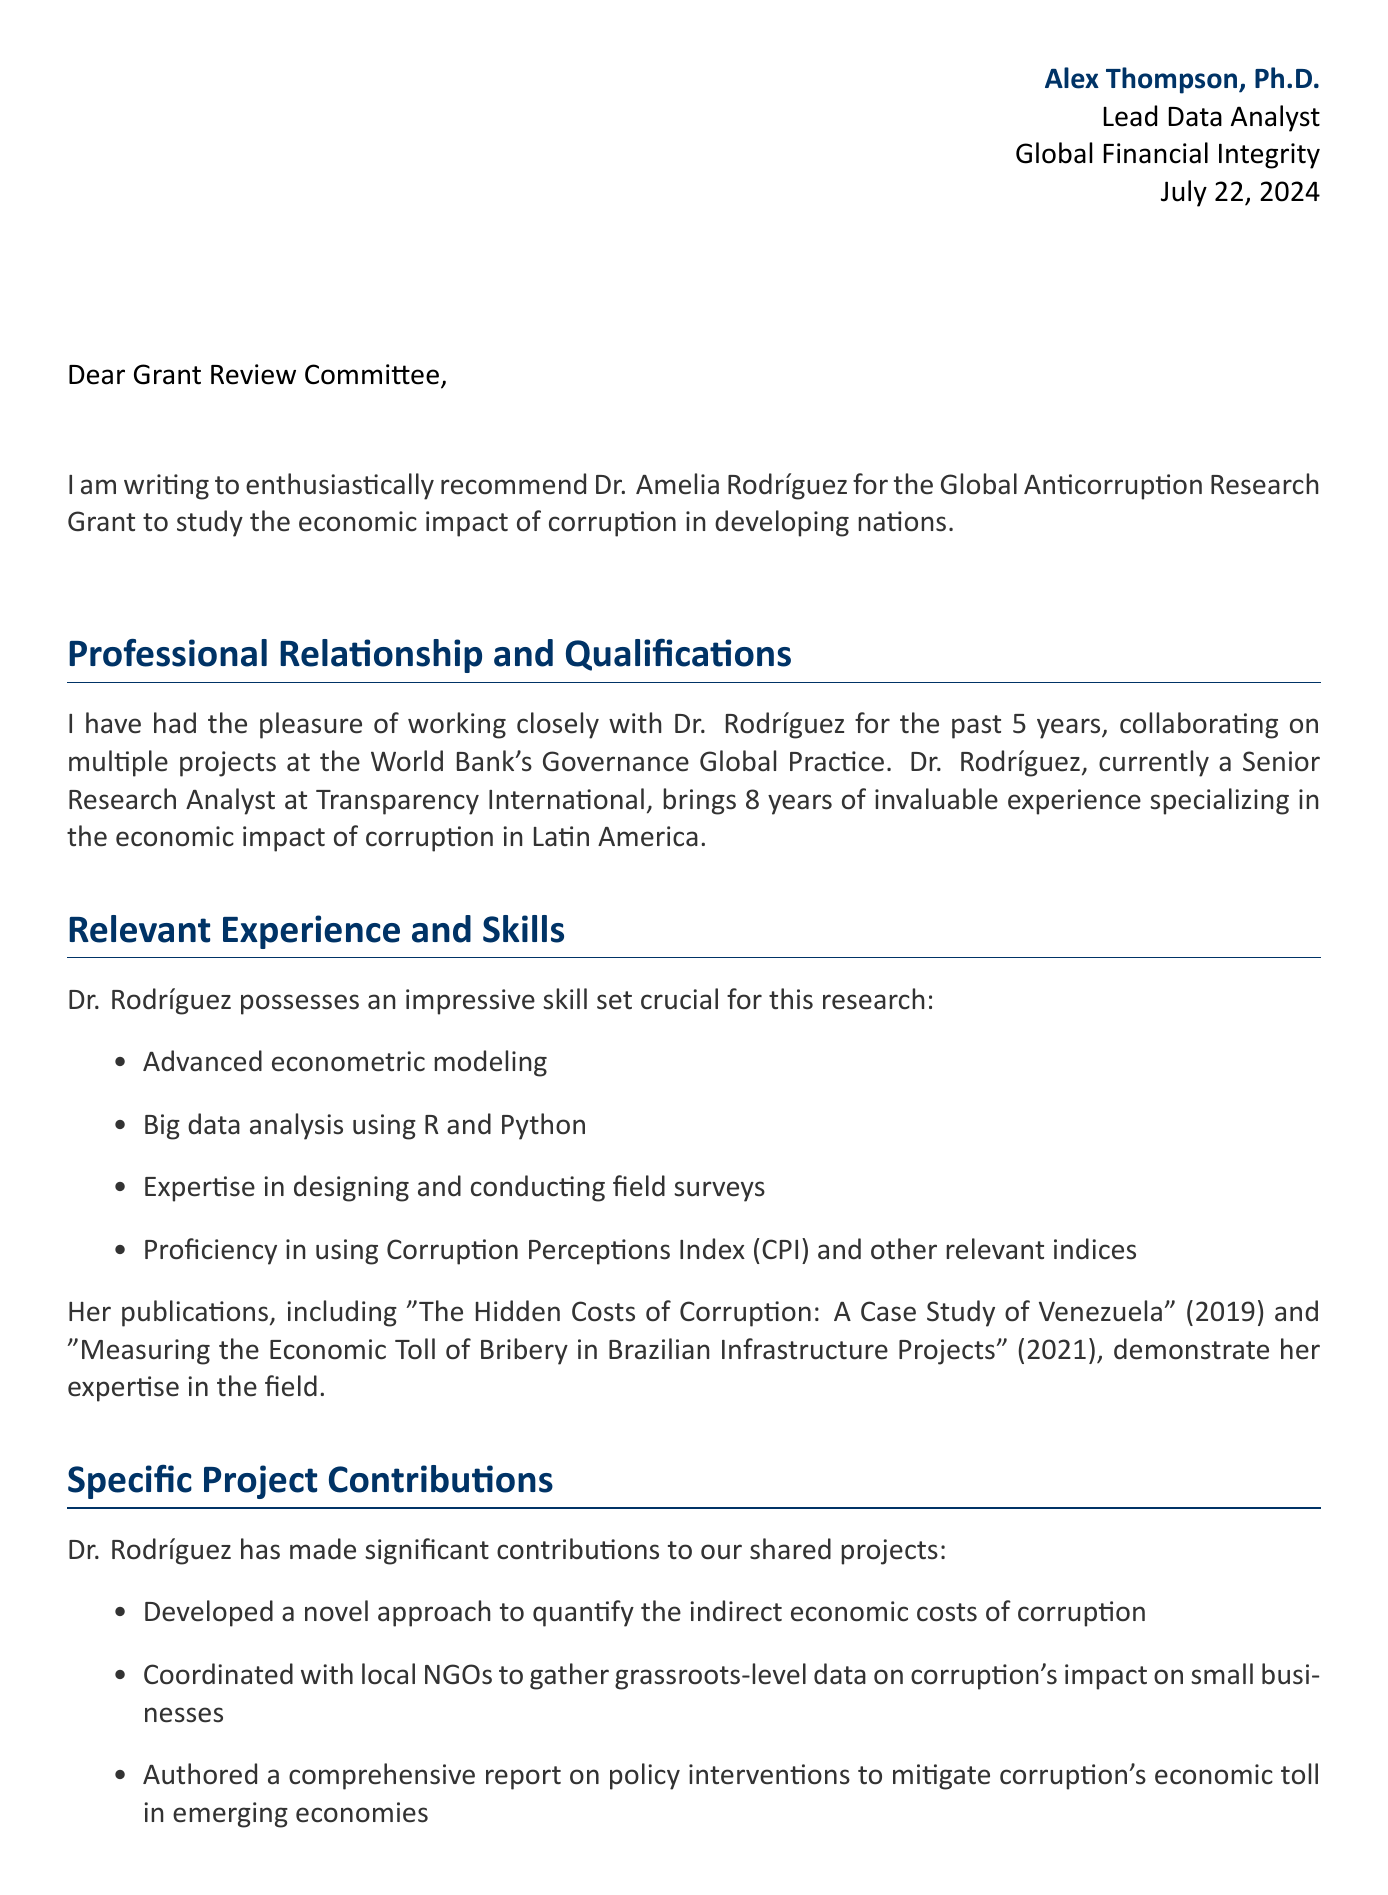What is the name of the colleague being recommended? The letter explicitly states the name of the colleague being recommended for the grant.
Answer: Dr. Amelia Rodríguez How many years of experience does Dr. Rodríguez have? The letter mentions Dr. Rodríguez's total years of relevant experience in the field of economic impact of corruption.
Answer: 8 What is the title of Dr. Rodríguez's proposed study? The document provides the exact title of the proposed study that Dr. Rodríguez intends to conduct with the grant.
Answer: Quantifying the Ripple Effects: Economic Consequences of Corruption in BRICS Nations What is the organization offering the grant? The document specifies the organization that is providing the funding for the proposed study.
Answer: United Nations Office on Drugs and Crime How many publications are listed in the letter? The letter lists Dr. Rodríguez's relevant publications to demonstrate her expertise in the subject matter.
Answer: 2 What position does Alex Thompson hold? The letter includes details about the writer's current position to establish credibility in the recommendation.
Answer: Lead Data Analyst What amount of funding is being requested for the grant? The document indicates the total funding amount that Dr. Rodríguez is seeking for her research.
Answer: $250,000 What is the main focus of Dr. Rodríguez's research? The letter clearly indicates the core focus of Dr. Rodríguez's intended research project.
Answer: Economic impact of corruption in developing nations 